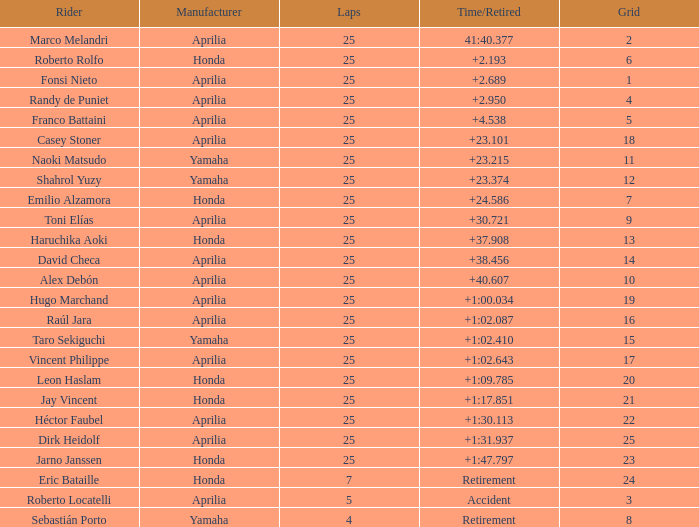Which laps possess a time/retired of +2 None. 